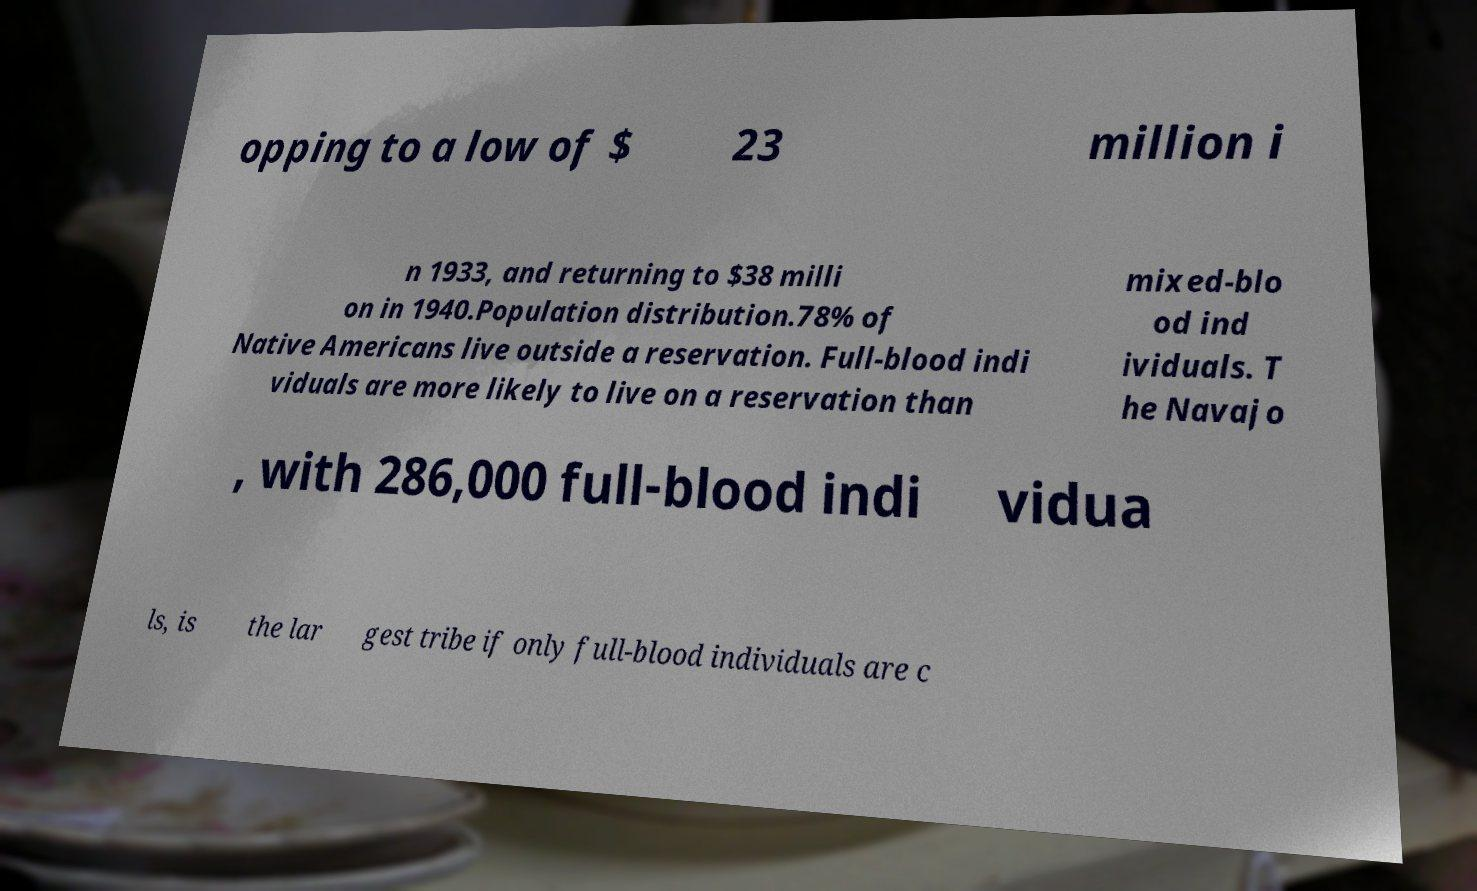What messages or text are displayed in this image? I need them in a readable, typed format. opping to a low of $ 23 million i n 1933, and returning to $38 milli on in 1940.Population distribution.78% of Native Americans live outside a reservation. Full-blood indi viduals are more likely to live on a reservation than mixed-blo od ind ividuals. T he Navajo , with 286,000 full-blood indi vidua ls, is the lar gest tribe if only full-blood individuals are c 